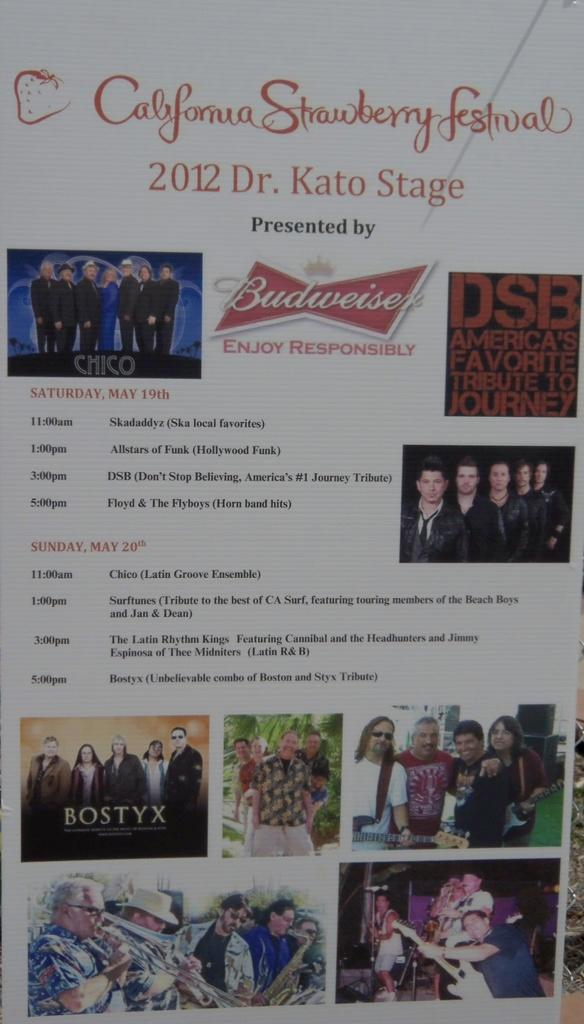Provide a one-sentence caption for the provided image. The California Strawberry festival is sponsored by Budweiser. 